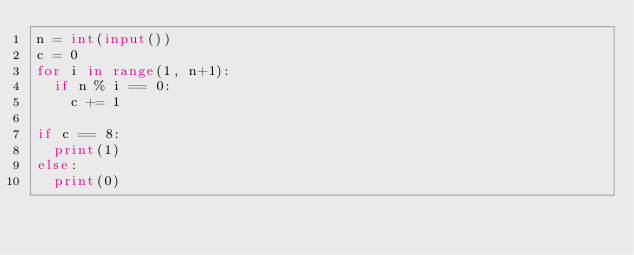<code> <loc_0><loc_0><loc_500><loc_500><_Python_>n = int(input())
c = 0
for i in range(1, n+1):
  if n % i == 0:
    c += 1
    
if c == 8:
  print(1)
else:
  print(0)</code> 